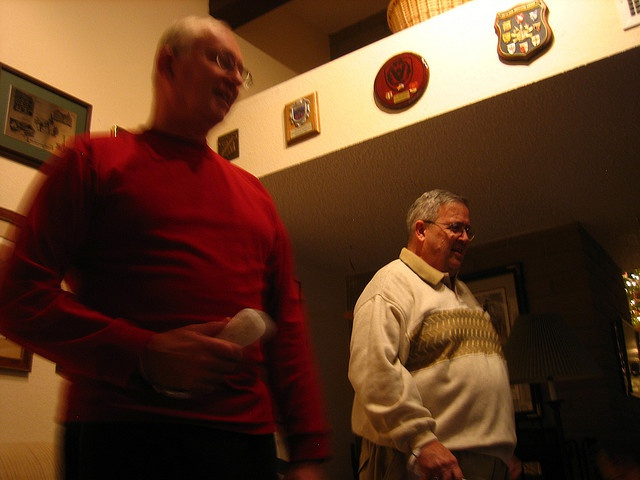Describe the objects in this image and their specific colors. I can see people in tan, black, maroon, and brown tones, people in tan, brown, maroon, and black tones, and remote in tan, maroon, and brown tones in this image. 